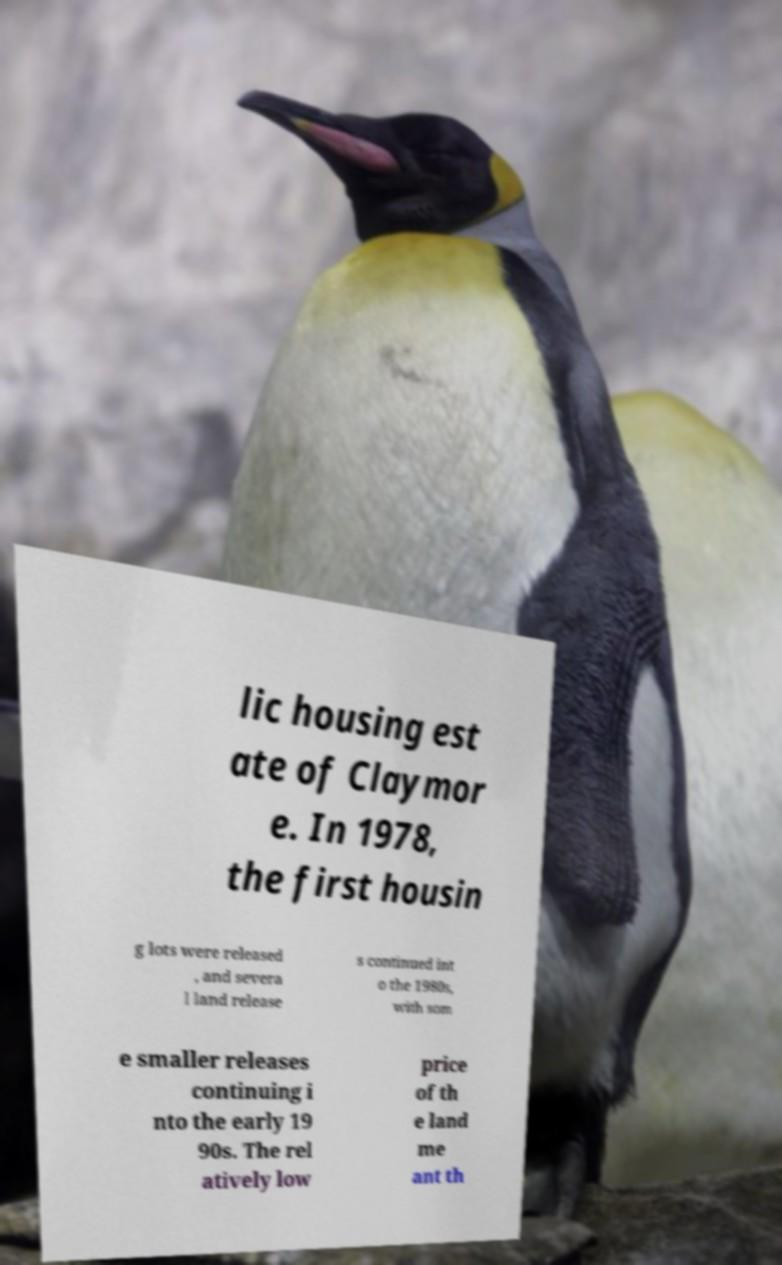Could you assist in decoding the text presented in this image and type it out clearly? lic housing est ate of Claymor e. In 1978, the first housin g lots were released , and severa l land release s continued int o the 1980s, with som e smaller releases continuing i nto the early 19 90s. The rel atively low price of th e land me ant th 